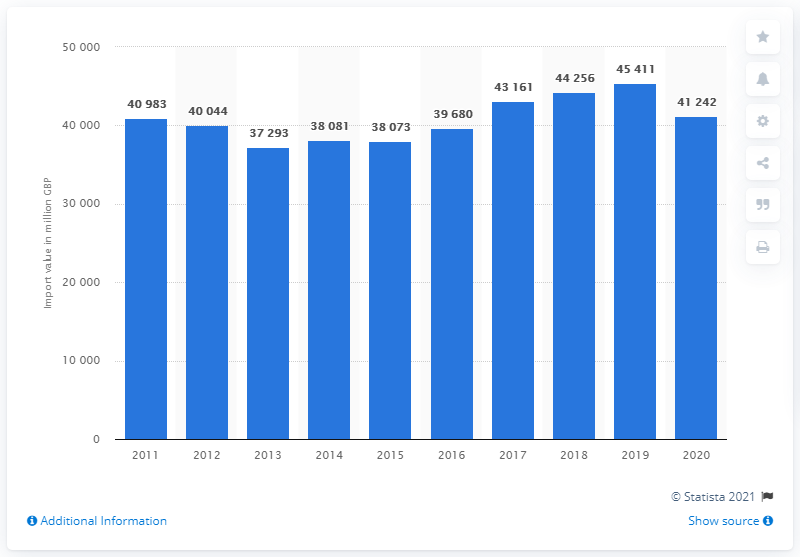Point out several critical features in this image. In 2020, the value of England's chemical imports was 41,242. In 2019, the value of England's chemical imports was 45,411. 